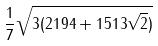<formula> <loc_0><loc_0><loc_500><loc_500>\frac { 1 } { 7 } \sqrt { 3 ( 2 1 9 4 + 1 5 1 3 \sqrt { 2 } ) }</formula> 